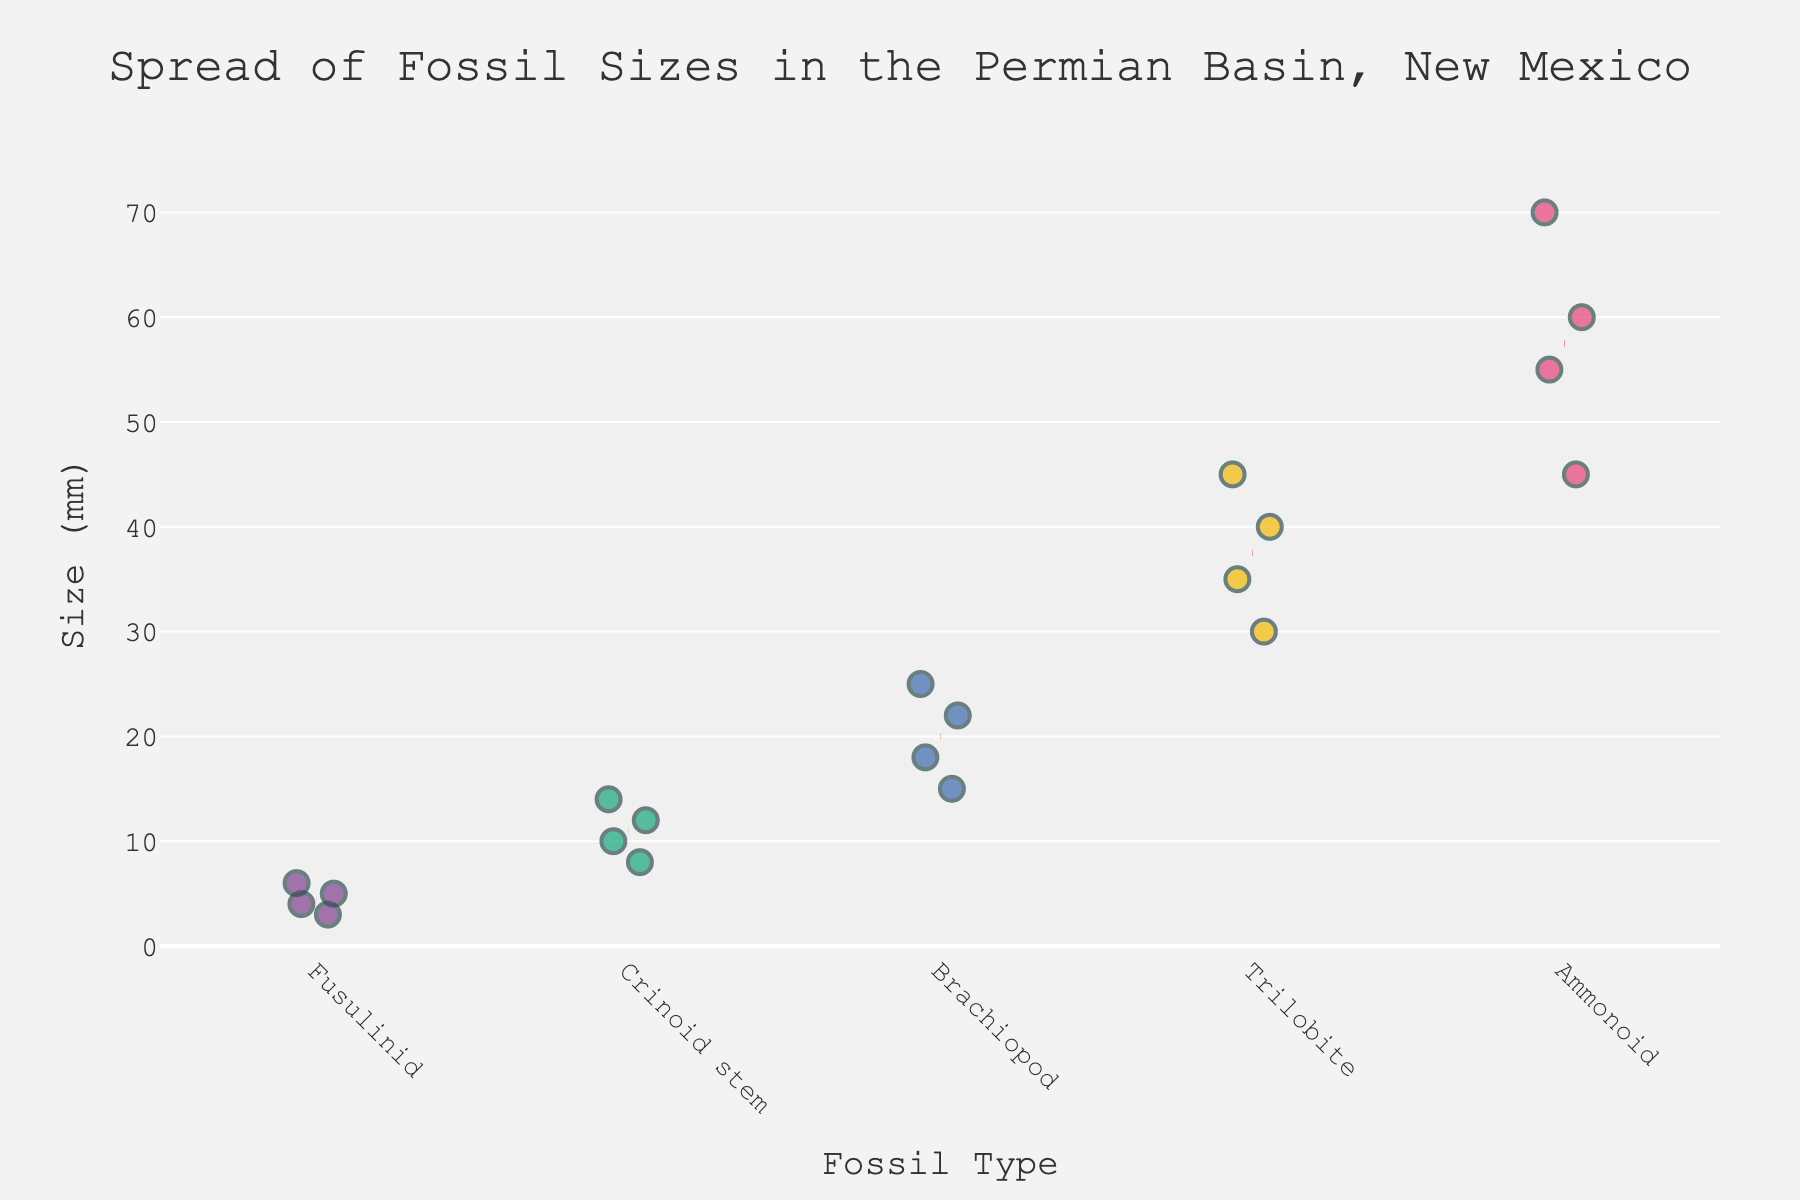What is the title of the figure? The title of the figure is displayed at the top and it provides an overview of what the plot represents. In this case, it is labeled "Spread of Fossil Sizes in the Permian Basin, New Mexico".
Answer: Spread of Fossil Sizes in the Permian Basin, New Mexico Which fossil type has the largest recorded size? By visually observing the position of the points on the y-axis, the Ammonoid fossil type reaches the highest value at 70 mm.
Answer: Ammonoid What is the range of sizes for Crinoid stems? The Crinoid stems' sizes range from the smallest to the largest value on the y-axis. The strip plot shows that Crinoid stems range from 8 mm to 14 mm.
Answer: 8 mm to 14 mm How many data points are there for each fossil type? Counting the number of points along each strip for every fossil type: Brachiopod (4), Crinoid stem (4), Fusulinid (4), Ammonoid (4), Trilobite (4).
Answer: 4 Which fossil type has the smallest average size? The red dashed line represents the mean size for each fossil type. The closest line to the bottom of the y-axis is for Fusulinids, indicating a smaller average size.
Answer: Fusulinid What is the difference in average size between Trilobites and Fusulinids? To find the difference, observe the mean lines (red dashed). The mean size of Trilobite is around 37.5 mm and Fusulinid is approximately 4.5 mm. The difference is 37.5 mm - 4.5 mm.
Answer: 33 mm Which fossil type exhibits the most variability in size? The fossil type whose points are spread the most along the y-axis shows greater size variability. Ammonoid points range from 45 mm to 70 mm, indicating high variability.
Answer: Ammonoid Are there any fossil types with overlapping size ranges, and if so, which ones? Overlapping size ranges occur when points from different fossil types align on the y-axis. Both Brachiopods (15-25 mm) and Crinoid stems (8-14 mm) do not overlap with any other fossil types' sizes. However, Fusulinids (3-6 mm) and Crinoid stems (8-14 mm) are close but not overlapping. Trilobites (30-45 mm) and Ammonoids (45-70 mm) do not overlap either.
Answer: No overlapping Which fossil type has sizes that mostly fall within the range of 40-50 mm? By looking at the points plotted between 40 mm and 50 mm on the y-axis, only Trilobites have multiple points within that range.
Answer: Trilobite Across all fossil types, what is the maximum size recorded? Identify the highest point on the y-axis across all strips. The highest point is an Ammonoid at 70 mm.
Answer: 70 mm 